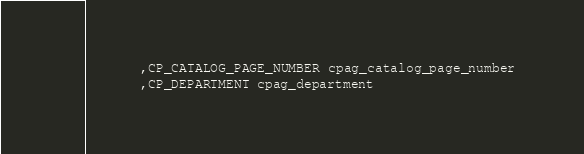Convert code to text. <code><loc_0><loc_0><loc_500><loc_500><_SQL_>       ,CP_CATALOG_PAGE_NUMBER cpag_catalog_page_number 
       ,CP_DEPARTMENT cpag_department
</code> 